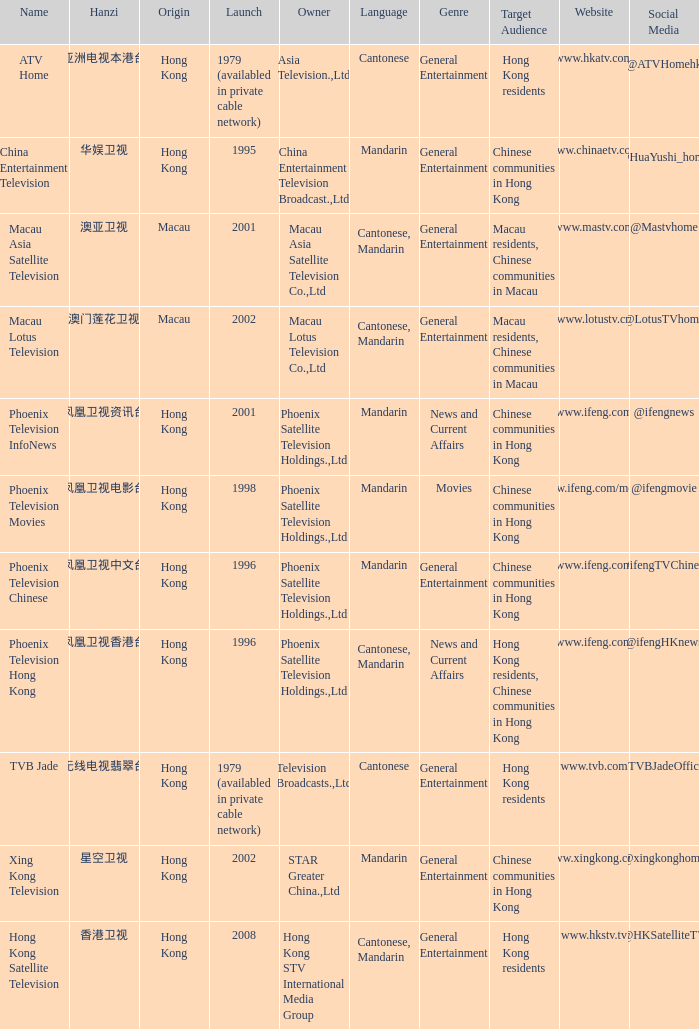Where did the Hanzi of 凤凰卫视电影台 originate? Hong Kong. Write the full table. {'header': ['Name', 'Hanzi', 'Origin', 'Launch', 'Owner', 'Language', 'Genre', 'Target Audience', 'Website', 'Social Media'], 'rows': [['ATV Home', '亚洲电视本港台', 'Hong Kong', '1979 (availabled in private cable network)', 'Asia Television.,Ltd', 'Cantonese', 'General Entertainment', 'Hong Kong residents', 'www.hkatv.com', '@ATVHomehk '], ['China Entertainment Television', '华娱卫视', 'Hong Kong', '1995', 'China Entertainment Television Broadcast.,Ltd', 'Mandarin', 'General Entertainment', 'Chinese communities in Hong Kong', 'www.chinaetv.com', '@HuaYushi_home '], ['Macau Asia Satellite Television', '澳亚卫视', 'Macau', '2001', 'Macau Asia Satellite Television Co.,Ltd', 'Cantonese, Mandarin', 'General Entertainment', 'Macau residents, Chinese communities in Macau', 'www.mastv.com', '@Mastvhome'], ['Macau Lotus Television', '澳门莲花卫视', 'Macau', '2002', 'Macau Lotus Television Co.,Ltd', 'Cantonese, Mandarin', 'General Entertainment', 'Macau residents, Chinese communities in Macau', 'www.lotustv.cn', '@LotusTVhome'], ['Phoenix Television InfoNews', '凤凰卫视资讯台', 'Hong Kong', '2001', 'Phoenix Satellite Television Holdings.,Ltd', 'Mandarin', 'News and Current Affairs', 'Chinese communities in Hong Kong', 'www.ifeng.com', '@ifengnews'], ['Phoenix Television Movies', '凤凰卫视电影台', 'Hong Kong', '1998', 'Phoenix Satellite Television Holdings.,Ltd', 'Mandarin', 'Movies', 'Chinese communities in Hong Kong', 'www.ifeng.com/movie', '@ifengmovie'], ['Phoenix Television Chinese', '凤凰卫视中文台', 'Hong Kong', '1996', 'Phoenix Satellite Television Holdings.,Ltd', 'Mandarin', 'General Entertainment', 'Chinese communities in Hong Kong', 'www.ifeng.com', '@ifengTVChinese'], ['Phoenix Television Hong Kong', '凤凰卫视香港台', 'Hong Kong', '1996', 'Phoenix Satellite Television Holdings.,Ltd', 'Cantonese, Mandarin', 'News and Current Affairs', 'Hong Kong residents, Chinese communities in Hong Kong', 'www.ifeng.com', '@ifengHKnews'], ['TVB Jade', '无线电视翡翠台', 'Hong Kong', '1979 (availabled in private cable network)', 'Television Broadcasts.,Ltd', 'Cantonese', 'General Entertainment', 'Hong Kong residents', 'www.tvb.com', '@TVBJadeOfficial'], ['Xing Kong Television', '星空卫视', 'Hong Kong', '2002', 'STAR Greater China.,Ltd', 'Mandarin', 'General Entertainment', 'Chinese communities in Hong Kong', 'www.xingkong.com', '@xingkonghome'], ['Hong Kong Satellite Television', '香港卫视', 'Hong Kong', '2008', 'Hong Kong STV International Media Group', 'Cantonese, Mandarin', 'General Entertainment', 'Hong Kong residents', 'www.hkstv.tv', '@HKSatelliteTV']]} 